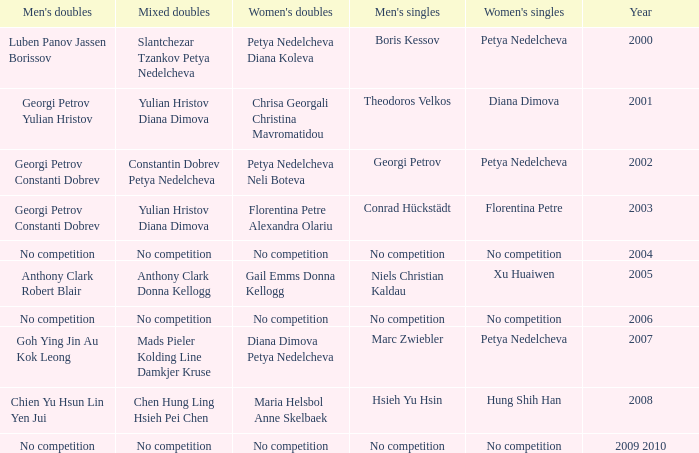Who won the Men's Double the same year as Florentina Petre winning the Women's Singles? Georgi Petrov Constanti Dobrev. 